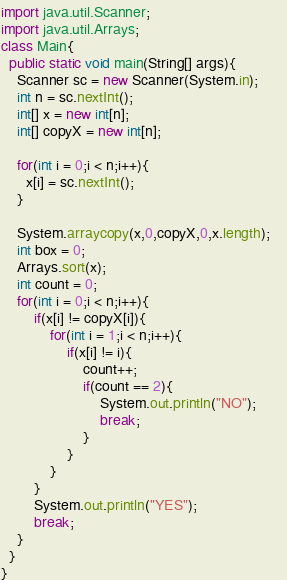<code> <loc_0><loc_0><loc_500><loc_500><_Java_>import java.util.Scanner;
import java.util.Arrays;
class Main{
  public static void main(String[] args){
    Scanner sc = new Scanner(System.in);
    int n = sc.nextInt();
	int[] x = new int[n];
    int[] copyX = new int[n];

    for(int i = 0;i < n;i++){
      x[i] = sc.nextInt();
    }

    System.arraycopy(x,0,copyX,0,x.length);    
    int box = 0;
    Arrays.sort(x);
    int count = 0;
    for(int i = 0;i < n;i++){
        if(x[i] != copyX[i]){
            for(int i = 1;i < n;i++){
                if(x[i] != i){
                    count++;
                    if(count == 2){
                        System.out.println("NO");
                        break;
                    }
                }
            }
        }
        System.out.println("YES");
        break;
    }
  }
}</code> 